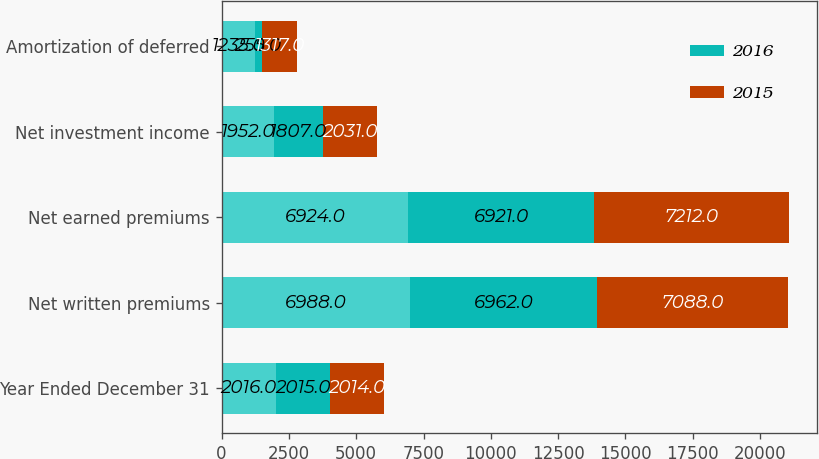Convert chart to OTSL. <chart><loc_0><loc_0><loc_500><loc_500><stacked_bar_chart><ecel><fcel>Year Ended December 31<fcel>Net written premiums<fcel>Net earned premiums<fcel>Net investment income<fcel>Amortization of deferred<nl><fcel>nan<fcel>2016<fcel>6988<fcel>6924<fcel>1952<fcel>1235<nl><fcel>2016<fcel>2015<fcel>6962<fcel>6921<fcel>1807<fcel>255<nl><fcel>2015<fcel>2014<fcel>7088<fcel>7212<fcel>2031<fcel>1317<nl></chart> 